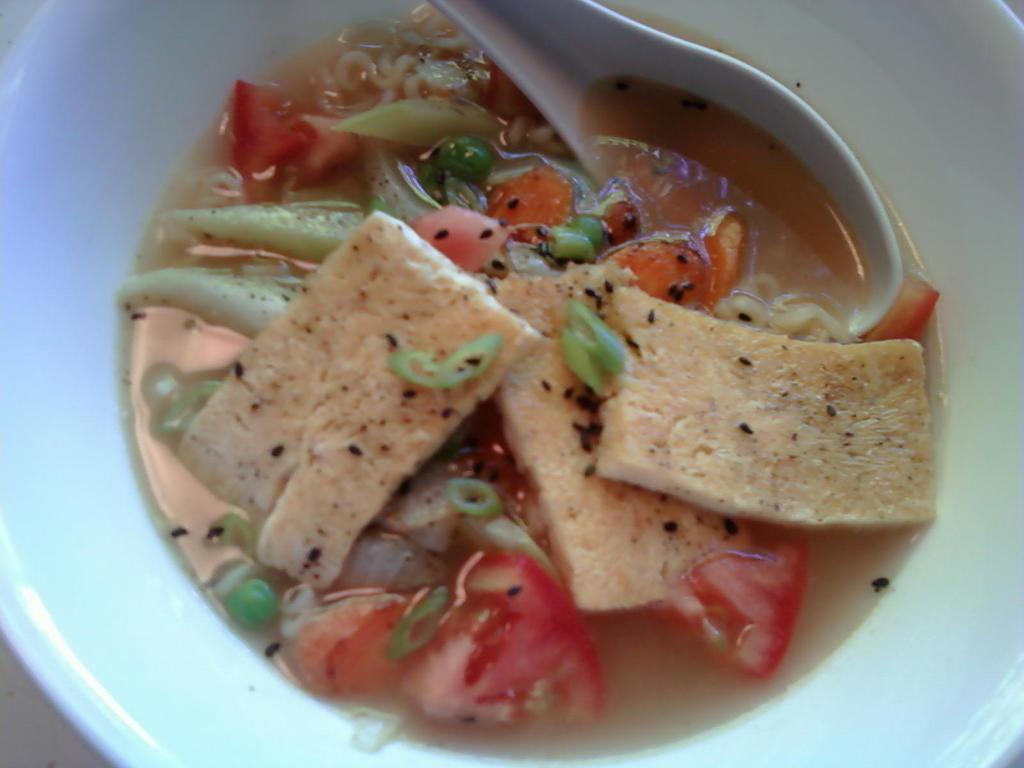In one or two sentences, can you explain what this image depicts? In this image I can see a food item in the bowl. There is a spoon in the bowl. 